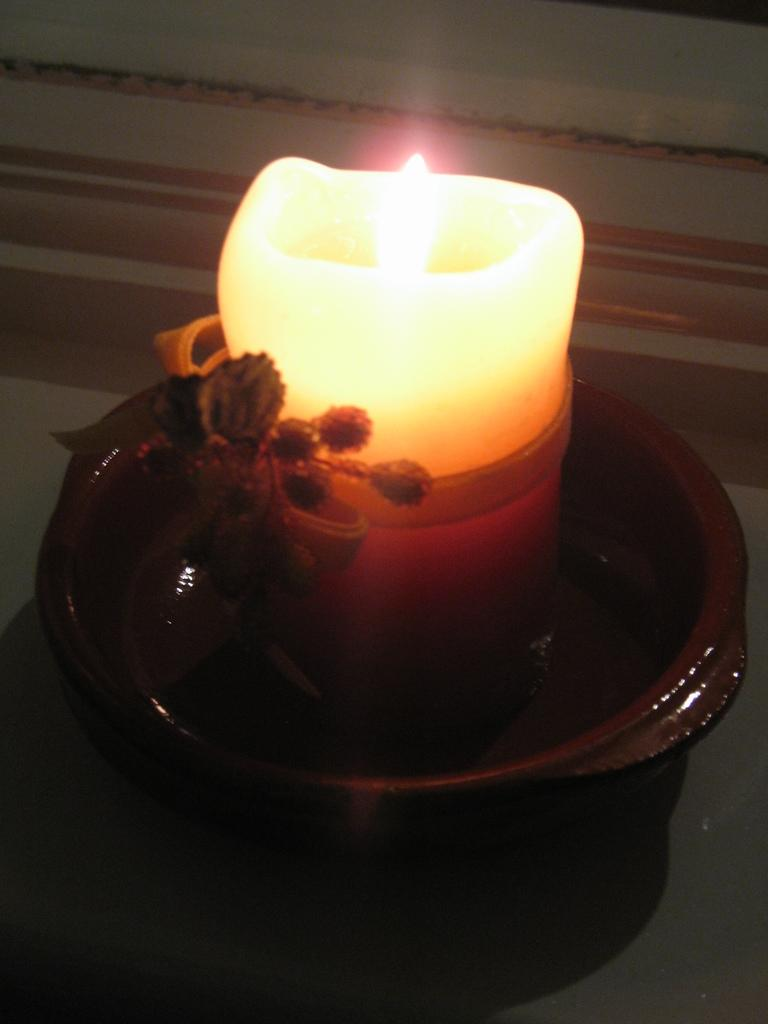What type of object is the main subject in the image? There is a clay candle pot in the image. Can you describe the color of the clay candle pot? The clay candle pot is light in color. Where is the clay candle pot placed in the image? The clay candle pot is placed on a white table. What is the color of the background in the image? The background of the image is white. Can you see any toads hopping on the grass in the image? There is no grass or toads present in the image; it features a clay candle pot on a white table with a white background. 